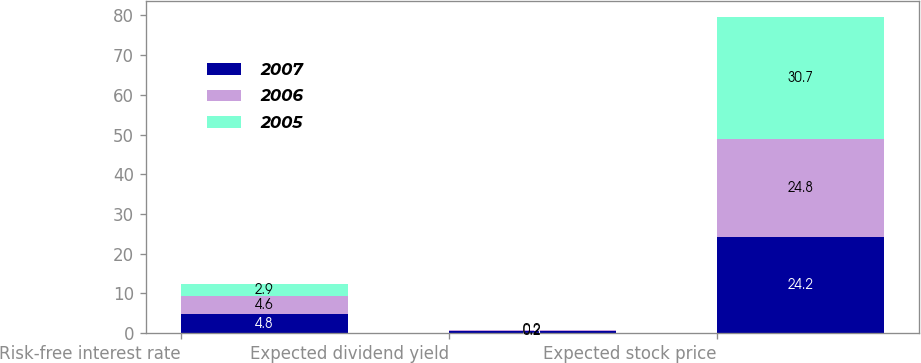<chart> <loc_0><loc_0><loc_500><loc_500><stacked_bar_chart><ecel><fcel>Risk-free interest rate<fcel>Expected dividend yield<fcel>Expected stock price<nl><fcel>2007<fcel>4.8<fcel>0.5<fcel>24.2<nl><fcel>2006<fcel>4.6<fcel>0.2<fcel>24.8<nl><fcel>2005<fcel>2.9<fcel>0.2<fcel>30.7<nl></chart> 